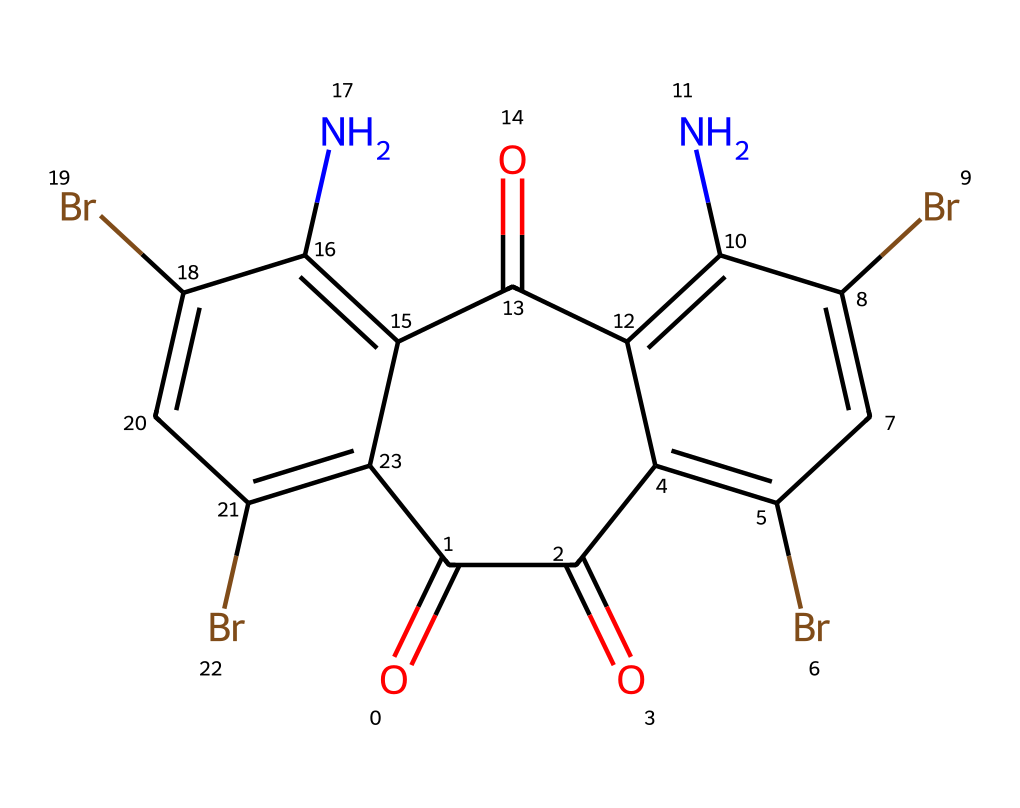What is the primary element present in this chemical's structure? The structure has a significant number of carbon atoms, as denoted by the presence of multiple carbon symbols in the SMILES representation. The "C" indicates the presence of carbon in the molecules.
Answer: carbon How many bromine atoms are in the structure? In the provided SMILES, "Br" appears four times, indicating four bromine atoms are incorporated in the chemical structure.
Answer: four What type of chemical compound is represented here? The presence of multiple functional groups, including carbonyl and amine groups, as well as its traditional usage as a dye, indicates that this is a type of dye known for its intense color.
Answer: dye What functional groups can be identified in the structural representation? Examining the SMILES, both carbonyl groups (“O=C”) and amine groups (“N”) are clearly visible, indicating that this compound features these functional groups.
Answer: carbonyl and amine What is the total number of rings in this chemical structure? Analyzing the structure, there are two interconnected benzene rings (six-membered carbon rings) based on the arrangement of carbon atoms in the cyclic structure.
Answer: two How many nitrogen atoms are present in the structure? The symbol "N" appears twice in the SMILES representation, indicating there are two nitrogen atoms in the chemical structure.
Answer: two 